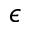Convert formula to latex. <formula><loc_0><loc_0><loc_500><loc_500>\epsilon</formula> 